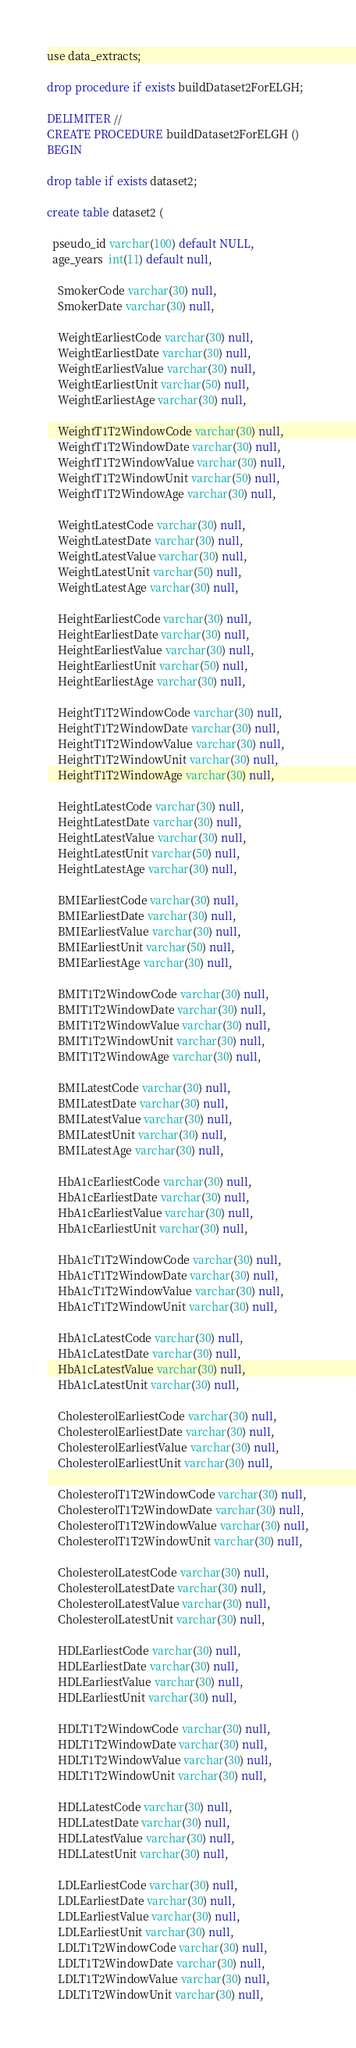Convert code to text. <code><loc_0><loc_0><loc_500><loc_500><_SQL_>use data_extracts;

drop procedure if exists buildDataset2ForELGH;

DELIMITER //
CREATE PROCEDURE buildDataset2ForELGH ()
BEGIN

drop table if exists dataset2;

create table dataset2 (

  pseudo_id varchar(100) default NULL,
  age_years  int(11) default null,

	SmokerCode varchar(30) null,
	SmokerDate varchar(30) null,

	WeightEarliestCode varchar(30) null,
	WeightEarliestDate varchar(30) null,
	WeightEarliestValue varchar(30) null,
	WeightEarliestUnit varchar(50) null,
	WeightEarliestAge varchar(30) null,

	WeightT1T2WindowCode varchar(30) null,
	WeightT1T2WindowDate varchar(30) null,
	WeightT1T2WindowValue varchar(30) null,
	WeightT1T2WindowUnit varchar(50) null,
	WeightT1T2WindowAge varchar(30) null,

	WeightLatestCode varchar(30) null,
	WeightLatestDate varchar(30) null,
	WeightLatestValue varchar(30) null,
	WeightLatestUnit varchar(50) null,
	WeightLatestAge varchar(30) null,

	HeightEarliestCode varchar(30) null,
	HeightEarliestDate varchar(30) null,
	HeightEarliestValue varchar(30) null,
	HeightEarliestUnit varchar(50) null,
	HeightEarliestAge varchar(30) null,

	HeightT1T2WindowCode varchar(30) null,
	HeightT1T2WindowDate varchar(30) null,
	HeightT1T2WindowValue varchar(30) null,
	HeightT1T2WindowUnit varchar(30) null,
	HeightT1T2WindowAge varchar(30) null,

	HeightLatestCode varchar(30) null,
	HeightLatestDate varchar(30) null,
	HeightLatestValue varchar(30) null,
	HeightLatestUnit varchar(50) null,
	HeightLatestAge varchar(30) null,

	BMIEarliestCode varchar(30) null,
	BMIEarliestDate varchar(30) null,
	BMIEarliestValue varchar(30) null,
	BMIEarliestUnit varchar(50) null,
	BMIEarliestAge varchar(30) null,

	BMIT1T2WindowCode varchar(30) null,
	BMIT1T2WindowDate varchar(30) null,
	BMIT1T2WindowValue varchar(30) null,
	BMIT1T2WindowUnit varchar(30) null,
	BMIT1T2WindowAge varchar(30) null,

	BMILatestCode varchar(30) null,
	BMILatestDate varchar(30) null,
	BMILatestValue varchar(30) null,
	BMILatestUnit varchar(30) null,
	BMILatestAge varchar(30) null,

	HbA1cEarliestCode varchar(30) null,
	HbA1cEarliestDate varchar(30) null,
	HbA1cEarliestValue varchar(30) null,
	HbA1cEarliestUnit varchar(30) null,

	HbA1cT1T2WindowCode varchar(30) null,
	HbA1cT1T2WindowDate varchar(30) null,
	HbA1cT1T2WindowValue varchar(30) null,
	HbA1cT1T2WindowUnit varchar(30) null,

	HbA1cLatestCode varchar(30) null,
	HbA1cLatestDate varchar(30) null,
	HbA1cLatestValue varchar(30) null,
	HbA1cLatestUnit varchar(30) null,

	CholesterolEarliestCode varchar(30) null,
	CholesterolEarliestDate varchar(30) null,
	CholesterolEarliestValue varchar(30) null,
	CholesterolEarliestUnit varchar(30) null,

	CholesterolT1T2WindowCode varchar(30) null,
	CholesterolT1T2WindowDate varchar(30) null,
	CholesterolT1T2WindowValue varchar(30) null,
	CholesterolT1T2WindowUnit varchar(30) null,

	CholesterolLatestCode varchar(30) null,
	CholesterolLatestDate varchar(30) null,
	CholesterolLatestValue varchar(30) null,
	CholesterolLatestUnit varchar(30) null,

	HDLEarliestCode varchar(30) null,
	HDLEarliestDate varchar(30) null,
	HDLEarliestValue varchar(30) null,
	HDLEarliestUnit varchar(30) null,

	HDLT1T2WindowCode varchar(30) null,
	HDLT1T2WindowDate varchar(30) null,
	HDLT1T2WindowValue varchar(30) null,
	HDLT1T2WindowUnit varchar(30) null,

	HDLLatestCode varchar(30) null,
	HDLLatestDate varchar(30) null,
	HDLLatestValue varchar(30) null,
	HDLLatestUnit varchar(30) null,

	LDLEarliestCode varchar(30) null,
	LDLEarliestDate varchar(30) null,
	LDLEarliestValue varchar(30) null,
	LDLEarliestUnit varchar(30) null,
	LDLT1T2WindowCode varchar(30) null,
	LDLT1T2WindowDate varchar(30) null,
	LDLT1T2WindowValue varchar(30) null,
	LDLT1T2WindowUnit varchar(30) null,</code> 